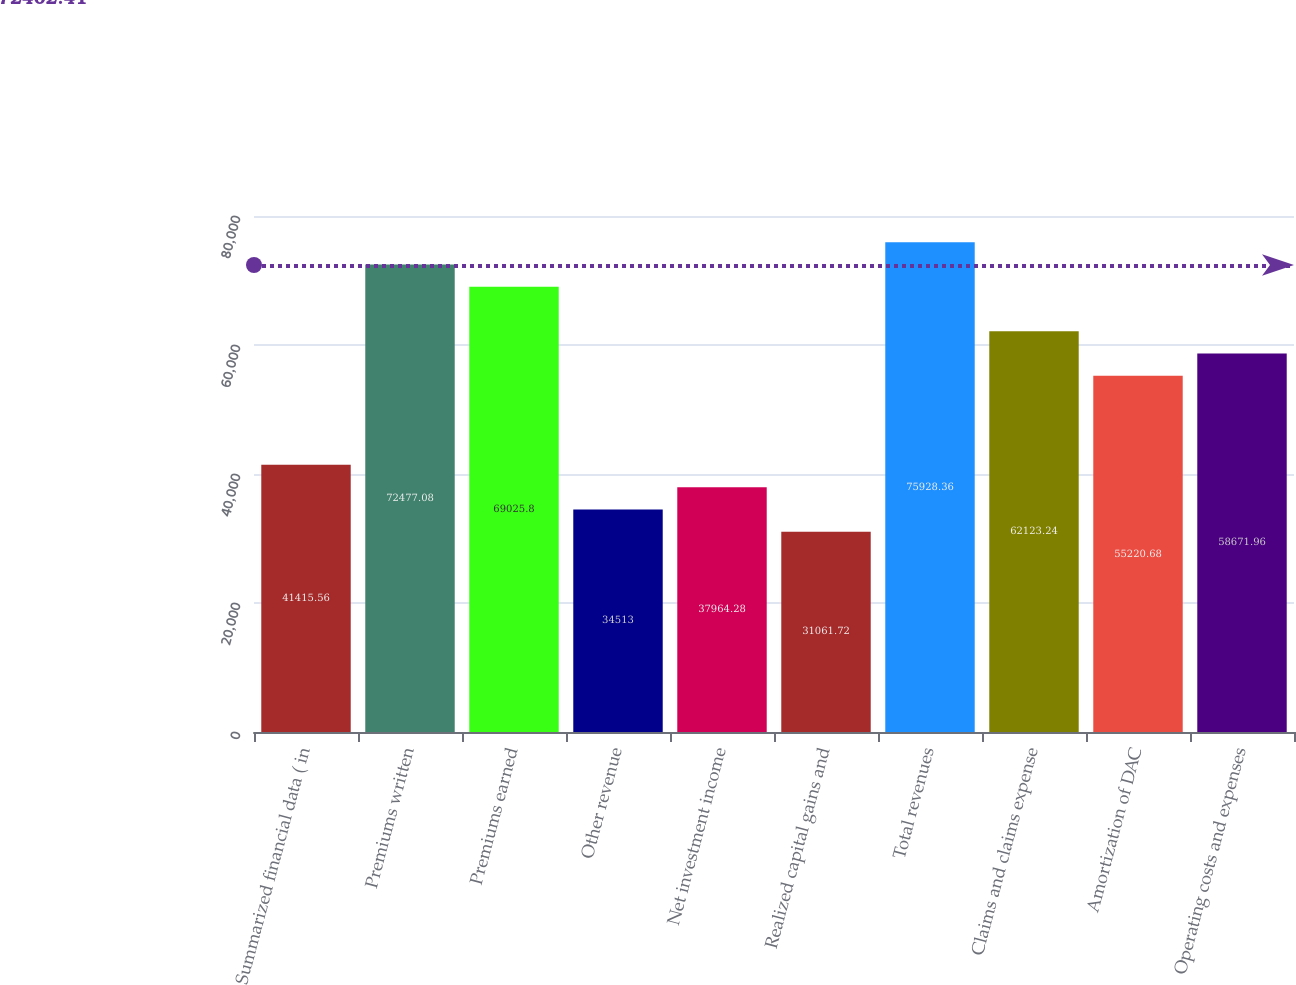<chart> <loc_0><loc_0><loc_500><loc_500><bar_chart><fcel>Summarized financial data ( in<fcel>Premiums written<fcel>Premiums earned<fcel>Other revenue<fcel>Net investment income<fcel>Realized capital gains and<fcel>Total revenues<fcel>Claims and claims expense<fcel>Amortization of DAC<fcel>Operating costs and expenses<nl><fcel>41415.6<fcel>72477.1<fcel>69025.8<fcel>34513<fcel>37964.3<fcel>31061.7<fcel>75928.4<fcel>62123.2<fcel>55220.7<fcel>58672<nl></chart> 